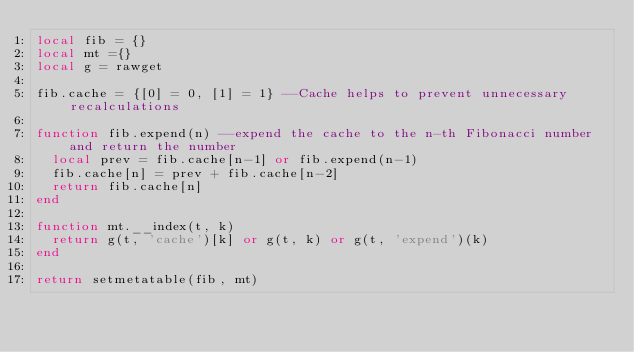<code> <loc_0><loc_0><loc_500><loc_500><_Lua_>local fib = {}
local mt ={}
local g = rawget

fib.cache = {[0] = 0, [1] = 1} --Cache helps to prevent unnecessary recalculations

function fib.expend(n) --expend the cache to the n-th Fibonacci number and return the number
  local prev = fib.cache[n-1] or fib.expend(n-1)
  fib.cache[n] = prev + fib.cache[n-2]
  return fib.cache[n]
end
 
function mt.__index(t, k)
  return g(t, 'cache')[k] or g(t, k) or g(t, 'expend')(k)
end

return setmetatable(fib, mt)
 </code> 